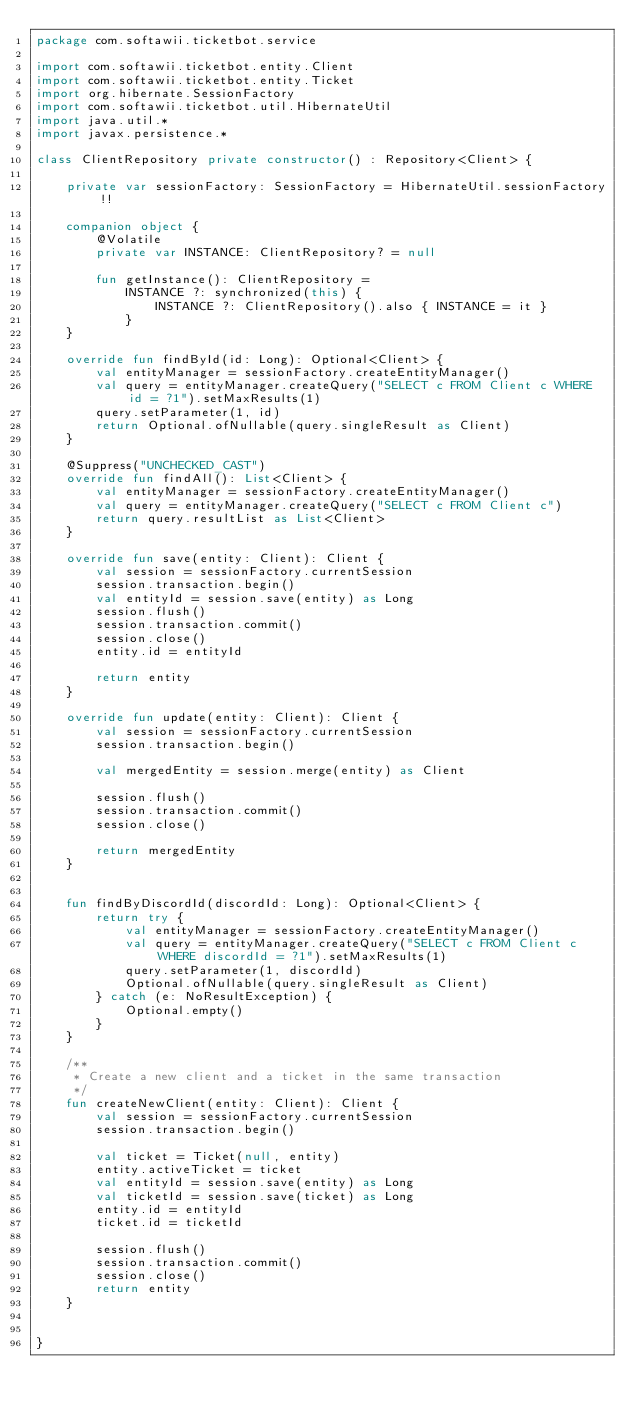Convert code to text. <code><loc_0><loc_0><loc_500><loc_500><_Kotlin_>package com.softawii.ticketbot.service

import com.softawii.ticketbot.entity.Client
import com.softawii.ticketbot.entity.Ticket
import org.hibernate.SessionFactory
import com.softawii.ticketbot.util.HibernateUtil
import java.util.*
import javax.persistence.*

class ClientRepository private constructor() : Repository<Client> {

    private var sessionFactory: SessionFactory = HibernateUtil.sessionFactory!!

    companion object {
        @Volatile
        private var INSTANCE: ClientRepository? = null

        fun getInstance(): ClientRepository =
            INSTANCE ?: synchronized(this) {
                INSTANCE ?: ClientRepository().also { INSTANCE = it }
            }
    }

    override fun findById(id: Long): Optional<Client> {
        val entityManager = sessionFactory.createEntityManager()
        val query = entityManager.createQuery("SELECT c FROM Client c WHERE id = ?1").setMaxResults(1)
        query.setParameter(1, id)
        return Optional.ofNullable(query.singleResult as Client)
    }

    @Suppress("UNCHECKED_CAST")
    override fun findAll(): List<Client> {
        val entityManager = sessionFactory.createEntityManager()
        val query = entityManager.createQuery("SELECT c FROM Client c")
        return query.resultList as List<Client>
    }

    override fun save(entity: Client): Client {
        val session = sessionFactory.currentSession
        session.transaction.begin()
        val entityId = session.save(entity) as Long
        session.flush()
        session.transaction.commit()
        session.close()
        entity.id = entityId

        return entity
    }

    override fun update(entity: Client): Client {
        val session = sessionFactory.currentSession
        session.transaction.begin()

        val mergedEntity = session.merge(entity) as Client

        session.flush()
        session.transaction.commit()
        session.close()

        return mergedEntity
    }


    fun findByDiscordId(discordId: Long): Optional<Client> {
        return try {
            val entityManager = sessionFactory.createEntityManager()
            val query = entityManager.createQuery("SELECT c FROM Client c WHERE discordId = ?1").setMaxResults(1)
            query.setParameter(1, discordId)
            Optional.ofNullable(query.singleResult as Client)
        } catch (e: NoResultException) {
            Optional.empty()
        }
    }

    /**
     * Create a new client and a ticket in the same transaction
     */
    fun createNewClient(entity: Client): Client {
        val session = sessionFactory.currentSession
        session.transaction.begin()

        val ticket = Ticket(null, entity)
        entity.activeTicket = ticket
        val entityId = session.save(entity) as Long
        val ticketId = session.save(ticket) as Long
        entity.id = entityId
        ticket.id = ticketId

        session.flush()
        session.transaction.commit()
        session.close()
        return entity
    }


}</code> 